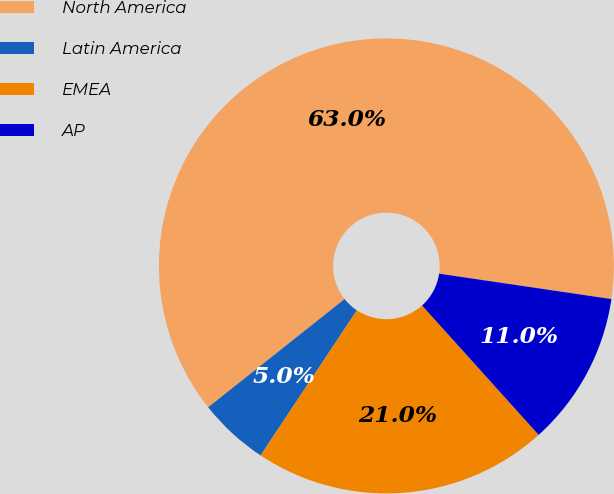Convert chart. <chart><loc_0><loc_0><loc_500><loc_500><pie_chart><fcel>North America<fcel>Latin America<fcel>EMEA<fcel>AP<nl><fcel>63.0%<fcel>5.0%<fcel>21.0%<fcel>11.0%<nl></chart> 